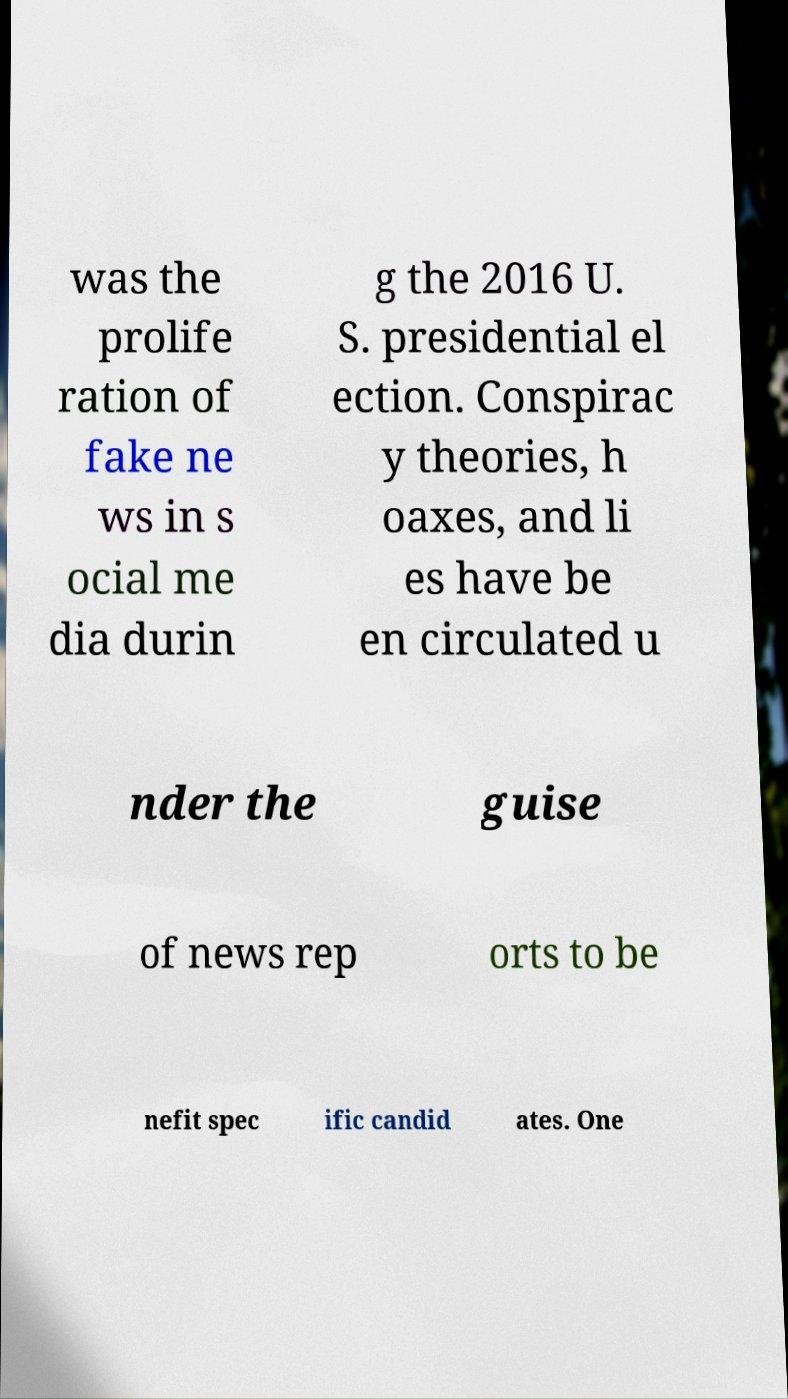Can you read and provide the text displayed in the image?This photo seems to have some interesting text. Can you extract and type it out for me? was the prolife ration of fake ne ws in s ocial me dia durin g the 2016 U. S. presidential el ection. Conspirac y theories, h oaxes, and li es have be en circulated u nder the guise of news rep orts to be nefit spec ific candid ates. One 